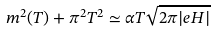Convert formula to latex. <formula><loc_0><loc_0><loc_500><loc_500>m ^ { 2 } ( T ) + \pi ^ { 2 } T ^ { 2 } \simeq \alpha T \sqrt { 2 \pi | e H | }</formula> 